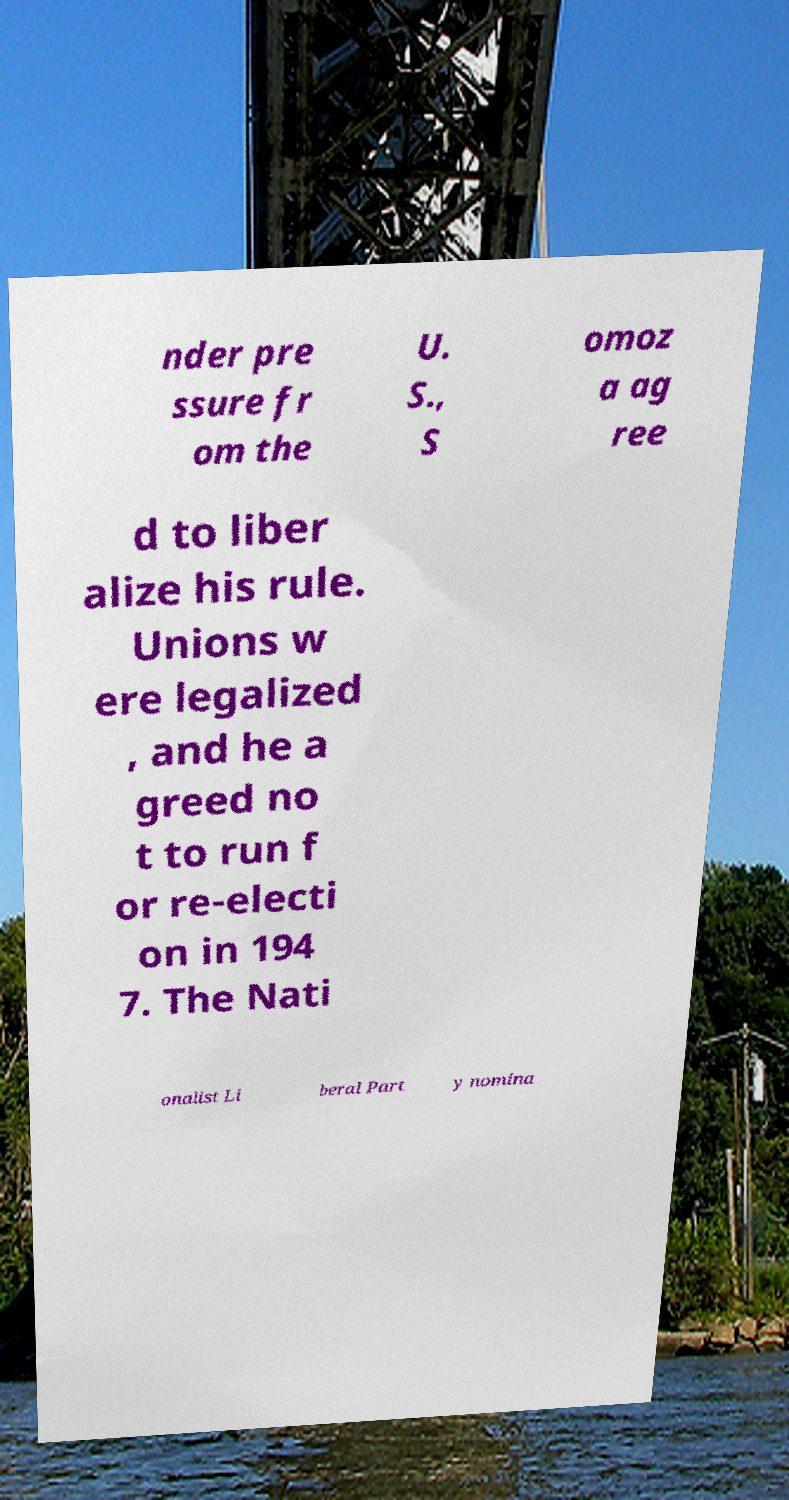For documentation purposes, I need the text within this image transcribed. Could you provide that? nder pre ssure fr om the U. S., S omoz a ag ree d to liber alize his rule. Unions w ere legalized , and he a greed no t to run f or re-electi on in 194 7. The Nati onalist Li beral Part y nomina 